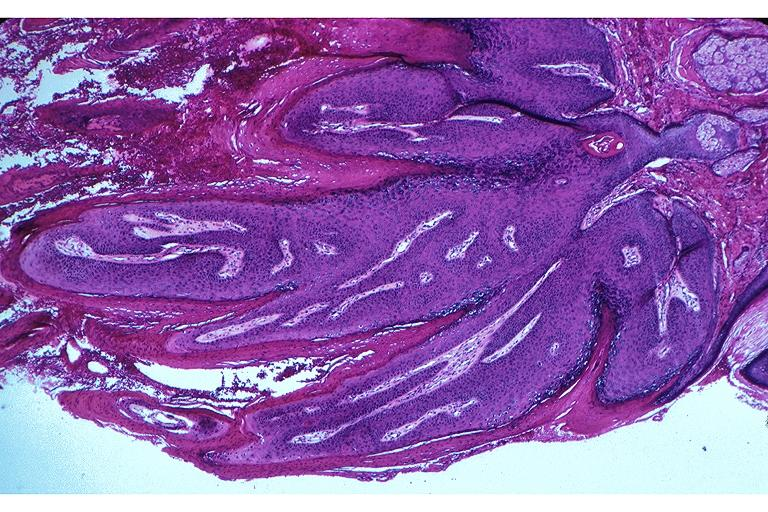does this image show papilloma?
Answer the question using a single word or phrase. Yes 